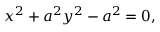Convert formula to latex. <formula><loc_0><loc_0><loc_500><loc_500>x ^ { 2 } + a ^ { 2 } y ^ { 2 } - a ^ { 2 } = 0 ,</formula> 